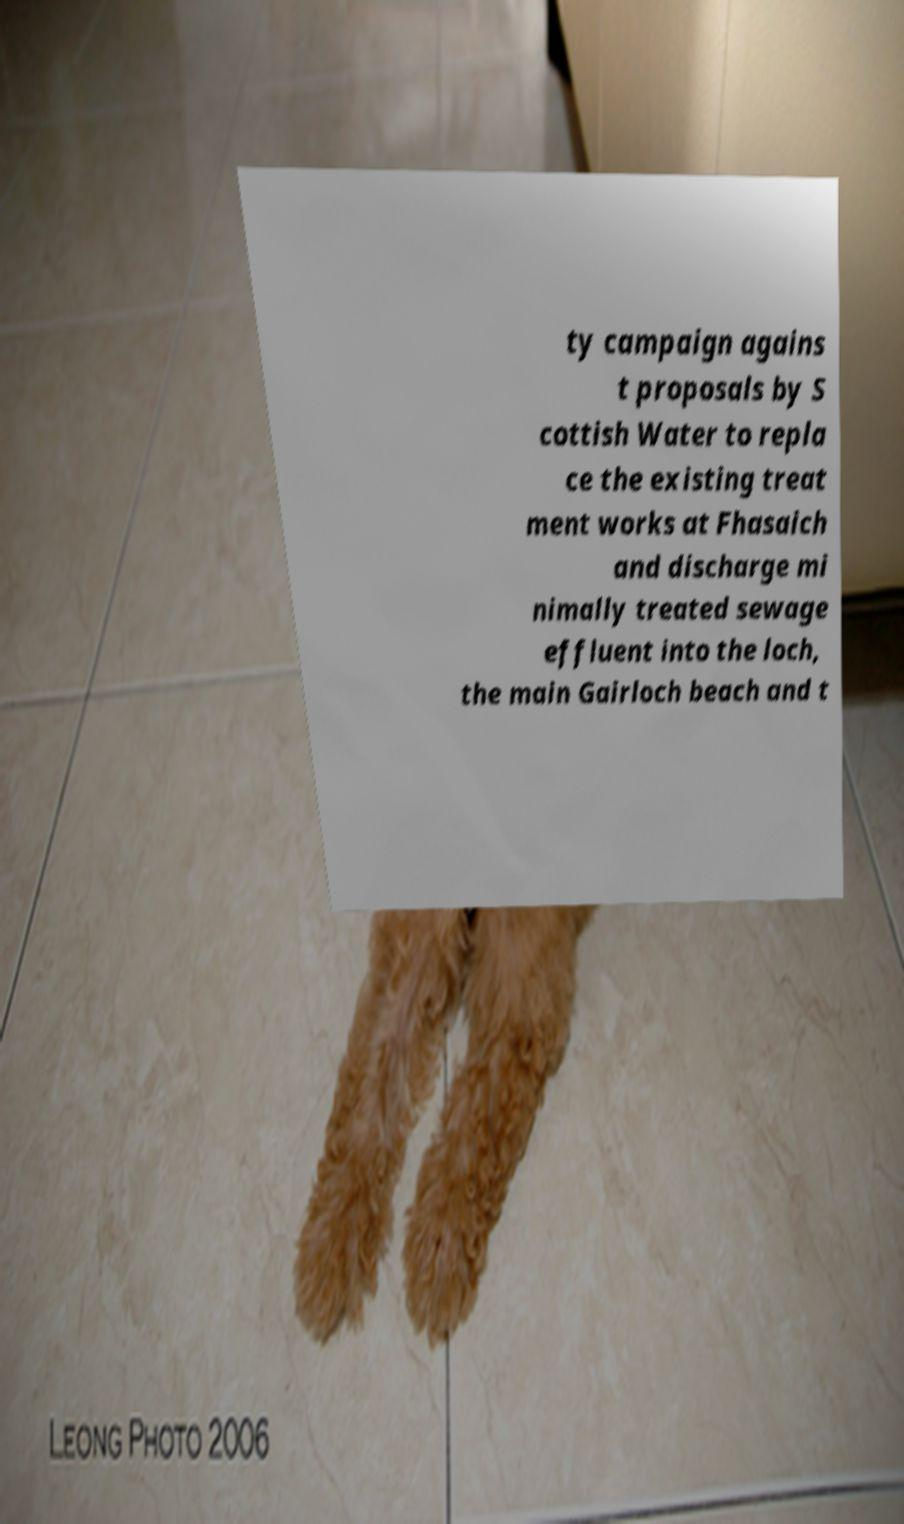Can you accurately transcribe the text from the provided image for me? ty campaign agains t proposals by S cottish Water to repla ce the existing treat ment works at Fhasaich and discharge mi nimally treated sewage effluent into the loch, the main Gairloch beach and t 